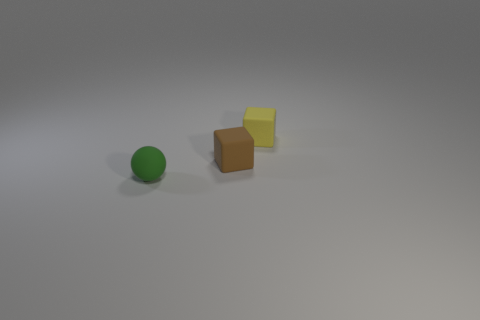How many other objects are there of the same size as the green sphere?
Provide a short and direct response. 2. There is a green thing in front of the small rubber object behind the small rubber cube in front of the yellow object; what shape is it?
Make the answer very short. Sphere. How many objects are either rubber things left of the brown matte cube or yellow blocks that are behind the small green rubber object?
Your answer should be very brief. 2. What size is the matte cube to the right of the rubber cube that is to the left of the tiny yellow cube?
Ensure brevity in your answer.  Small. Is there a tiny red metallic thing that has the same shape as the yellow matte object?
Ensure brevity in your answer.  No. What is the color of the other matte block that is the same size as the yellow matte block?
Provide a succinct answer. Brown. What size is the rubber thing that is in front of the tiny brown matte object?
Provide a succinct answer. Small. There is a small cube that is right of the tiny brown object; is there a small thing on the left side of it?
Give a very brief answer. Yes. How many rubber things are both in front of the brown object and behind the brown rubber object?
Ensure brevity in your answer.  0. How many small brown objects are made of the same material as the small brown cube?
Your answer should be compact. 0. 